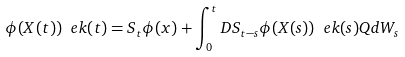<formula> <loc_0><loc_0><loc_500><loc_500>\phi ( X ( t ) ) \ e k ( t ) = S _ { t } \phi ( x ) + \int _ { 0 } ^ { t } D S _ { t - s } \phi ( X ( s ) ) \ e k ( s ) Q d W _ { s }</formula> 